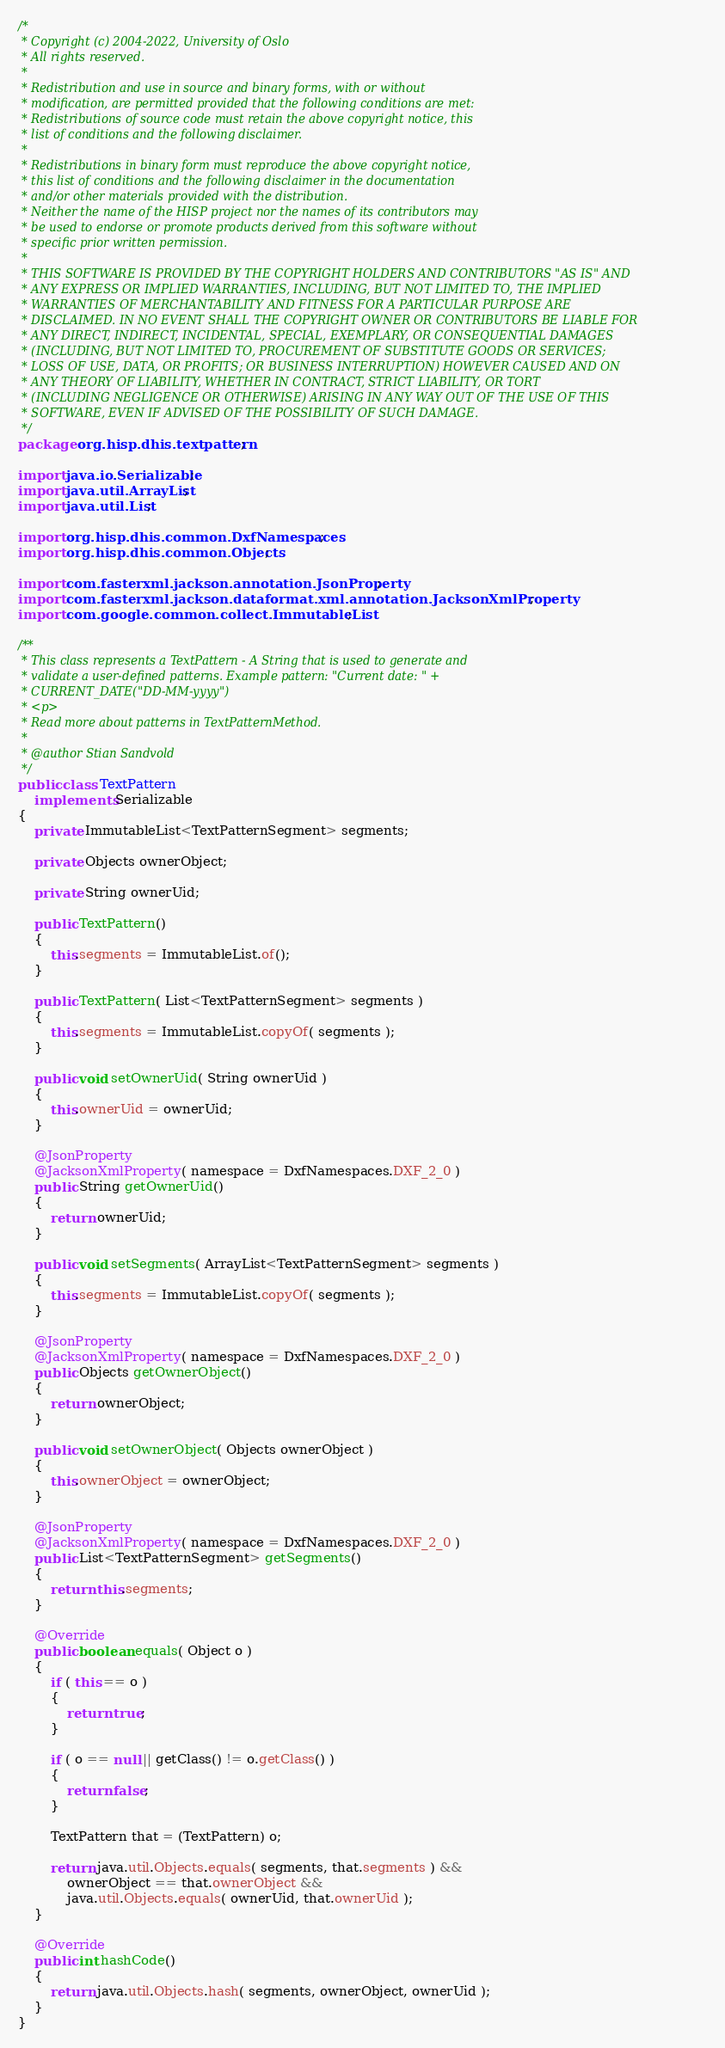<code> <loc_0><loc_0><loc_500><loc_500><_Java_>/*
 * Copyright (c) 2004-2022, University of Oslo
 * All rights reserved.
 *
 * Redistribution and use in source and binary forms, with or without
 * modification, are permitted provided that the following conditions are met:
 * Redistributions of source code must retain the above copyright notice, this
 * list of conditions and the following disclaimer.
 *
 * Redistributions in binary form must reproduce the above copyright notice,
 * this list of conditions and the following disclaimer in the documentation
 * and/or other materials provided with the distribution.
 * Neither the name of the HISP project nor the names of its contributors may
 * be used to endorse or promote products derived from this software without
 * specific prior written permission.
 *
 * THIS SOFTWARE IS PROVIDED BY THE COPYRIGHT HOLDERS AND CONTRIBUTORS "AS IS" AND
 * ANY EXPRESS OR IMPLIED WARRANTIES, INCLUDING, BUT NOT LIMITED TO, THE IMPLIED
 * WARRANTIES OF MERCHANTABILITY AND FITNESS FOR A PARTICULAR PURPOSE ARE
 * DISCLAIMED. IN NO EVENT SHALL THE COPYRIGHT OWNER OR CONTRIBUTORS BE LIABLE FOR
 * ANY DIRECT, INDIRECT, INCIDENTAL, SPECIAL, EXEMPLARY, OR CONSEQUENTIAL DAMAGES
 * (INCLUDING, BUT NOT LIMITED TO, PROCUREMENT OF SUBSTITUTE GOODS OR SERVICES;
 * LOSS OF USE, DATA, OR PROFITS; OR BUSINESS INTERRUPTION) HOWEVER CAUSED AND ON
 * ANY THEORY OF LIABILITY, WHETHER IN CONTRACT, STRICT LIABILITY, OR TORT
 * (INCLUDING NEGLIGENCE OR OTHERWISE) ARISING IN ANY WAY OUT OF THE USE OF THIS
 * SOFTWARE, EVEN IF ADVISED OF THE POSSIBILITY OF SUCH DAMAGE.
 */
package org.hisp.dhis.textpattern;

import java.io.Serializable;
import java.util.ArrayList;
import java.util.List;

import org.hisp.dhis.common.DxfNamespaces;
import org.hisp.dhis.common.Objects;

import com.fasterxml.jackson.annotation.JsonProperty;
import com.fasterxml.jackson.dataformat.xml.annotation.JacksonXmlProperty;
import com.google.common.collect.ImmutableList;

/**
 * This class represents a TextPattern - A String that is used to generate and
 * validate a user-defined patterns. Example pattern: "Current date: " +
 * CURRENT_DATE("DD-MM-yyyy")
 * <p>
 * Read more about patterns in TextPatternMethod.
 *
 * @author Stian Sandvold
 */
public class TextPattern
    implements Serializable
{
    private ImmutableList<TextPatternSegment> segments;

    private Objects ownerObject;

    private String ownerUid;

    public TextPattern()
    {
        this.segments = ImmutableList.of();
    }

    public TextPattern( List<TextPatternSegment> segments )
    {
        this.segments = ImmutableList.copyOf( segments );
    }

    public void setOwnerUid( String ownerUid )
    {
        this.ownerUid = ownerUid;
    }

    @JsonProperty
    @JacksonXmlProperty( namespace = DxfNamespaces.DXF_2_0 )
    public String getOwnerUid()
    {
        return ownerUid;
    }

    public void setSegments( ArrayList<TextPatternSegment> segments )
    {
        this.segments = ImmutableList.copyOf( segments );
    }

    @JsonProperty
    @JacksonXmlProperty( namespace = DxfNamespaces.DXF_2_0 )
    public Objects getOwnerObject()
    {
        return ownerObject;
    }

    public void setOwnerObject( Objects ownerObject )
    {
        this.ownerObject = ownerObject;
    }

    @JsonProperty
    @JacksonXmlProperty( namespace = DxfNamespaces.DXF_2_0 )
    public List<TextPatternSegment> getSegments()
    {
        return this.segments;
    }

    @Override
    public boolean equals( Object o )
    {
        if ( this == o )
        {
            return true;
        }

        if ( o == null || getClass() != o.getClass() )
        {
            return false;
        }

        TextPattern that = (TextPattern) o;

        return java.util.Objects.equals( segments, that.segments ) &&
            ownerObject == that.ownerObject &&
            java.util.Objects.equals( ownerUid, that.ownerUid );
    }

    @Override
    public int hashCode()
    {
        return java.util.Objects.hash( segments, ownerObject, ownerUid );
    }
}
</code> 